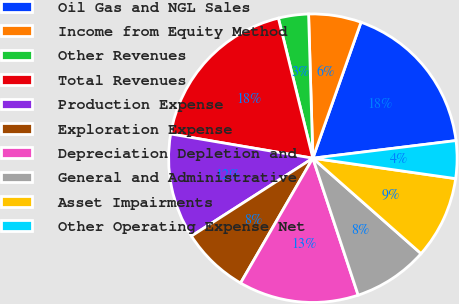Convert chart. <chart><loc_0><loc_0><loc_500><loc_500><pie_chart><fcel>Oil Gas and NGL Sales<fcel>Income from Equity Method<fcel>Other Revenues<fcel>Total Revenues<fcel>Production Expense<fcel>Exploration Expense<fcel>Depreciation Depletion and<fcel>General and Administrative<fcel>Asset Impairments<fcel>Other Operating Expense Net<nl><fcel>17.63%<fcel>5.89%<fcel>3.37%<fcel>18.47%<fcel>11.76%<fcel>7.57%<fcel>13.44%<fcel>8.41%<fcel>9.24%<fcel>4.21%<nl></chart> 